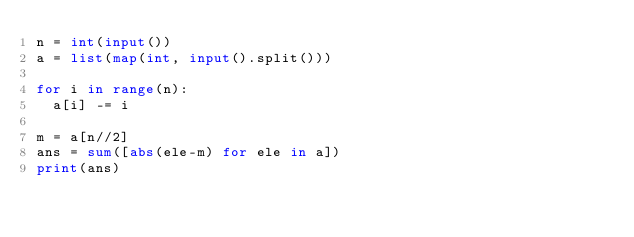<code> <loc_0><loc_0><loc_500><loc_500><_Python_>n = int(input())
a = list(map(int, input().split()))

for i in range(n):
  a[i] -= i

m = a[n//2]
ans = sum([abs(ele-m) for ele in a])
print(ans)</code> 